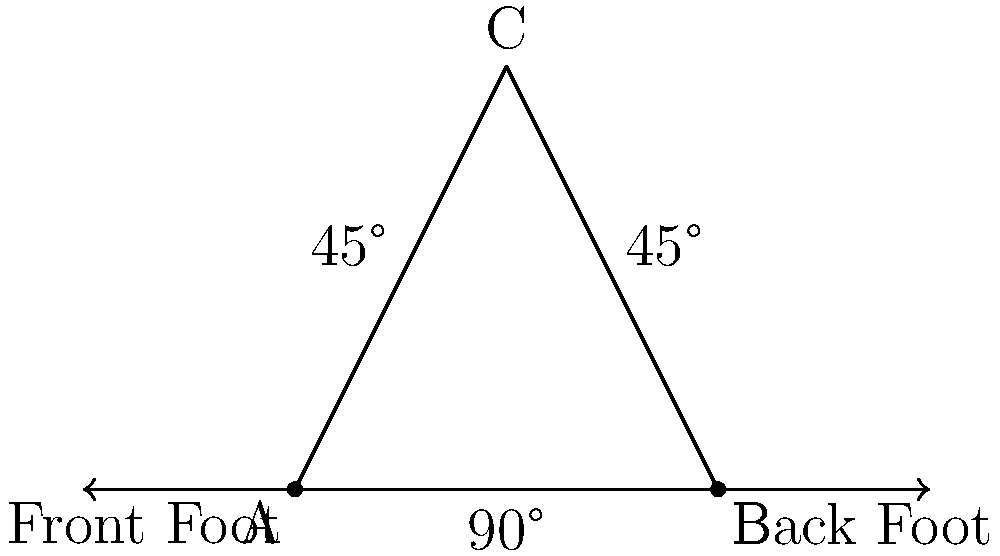In a typical kickboxing stance, the feet form a triangle as shown in the diagram. If the angle between the front foot and the line connecting both feet is 90°, and the triangle is isosceles, what is the angle formed by the back foot and the line connecting both feet? Let's approach this step-by-step:

1) In the diagram, we see a triangle formed by the front foot (A), back foot (B), and the point where the legs meet (C).

2) We're told that the angle between the front foot and the line connecting both feet is 90°. This is the angle at point A in the triangle.

3) We're also told that the triangle is isosceles. In an isosceles triangle, two sides are equal in length, which means two angles are also equal.

4) Given that one angle is 90°, and the triangle is isosceles, the other two angles must be equal to each other.

5) We know that the sum of angles in a triangle is always 180°. Let's call the unknown angle $x$. We can set up an equation:

   $90° + x + x = 180°$

6) Simplifying:
   $90° + 2x = 180°$
   $2x = 90°$
   $x = 45°$

7) Therefore, the angle formed by the back foot and the line connecting both feet is 45°.

This 45° angle is common in many martial arts stances as it provides a good balance between stability and mobility.
Answer: 45° 